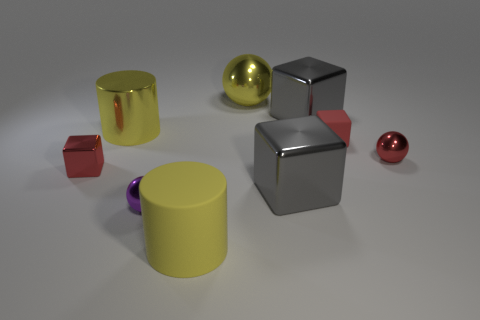Add 1 large shiny cylinders. How many objects exist? 10 Subtract all cylinders. How many objects are left? 7 Add 1 small red cylinders. How many small red cylinders exist? 1 Subtract 0 cyan cubes. How many objects are left? 9 Subtract all large yellow shiny spheres. Subtract all small red rubber blocks. How many objects are left? 7 Add 8 small red metal things. How many small red metal things are left? 10 